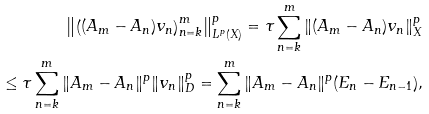Convert formula to latex. <formula><loc_0><loc_0><loc_500><loc_500>\left \| \left ( ( A _ { m } - A _ { n } ) v _ { n } \right ) _ { n = k } ^ { m } \right \| _ { L ^ { p } ( X ) } ^ { p } = \tau \sum _ { n = k } ^ { m } \| ( A _ { m } - A _ { n } ) v _ { n } \| _ { X } ^ { p } \\ \leq \tau \sum _ { n = k } ^ { m } \| A _ { m } - A _ { n } \| ^ { p } \| v _ { n } \| _ { D } ^ { p } = \sum _ { n = k } ^ { m } \| A _ { m } - A _ { n } \| ^ { p } ( E _ { n } - E _ { n - 1 } ) ,</formula> 